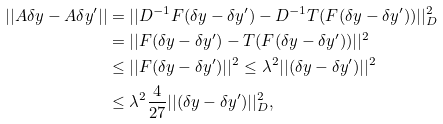<formula> <loc_0><loc_0><loc_500><loc_500>| | A \delta y - A \delta y ^ { \prime } | | & = | | D ^ { - 1 } F ( \delta y - \delta y ^ { \prime } ) - D ^ { - 1 } T ( F ( \delta y - \delta y ^ { \prime } ) ) | | ^ { 2 } _ { D } \\ & = | | F ( \delta y - \delta y ^ { \prime } ) - T ( F ( \delta y - \delta y ^ { \prime } ) ) | | ^ { 2 } \\ & \leq | | F ( \delta y - \delta y ^ { \prime } ) | | ^ { 2 } \leq \lambda ^ { 2 } | | ( \delta y - \delta y ^ { \prime } ) | | ^ { 2 } \\ & \leq \lambda ^ { 2 } \frac { 4 } { 2 7 } | | ( \delta y - \delta y ^ { \prime } ) | | ^ { 2 } _ { D } ,</formula> 